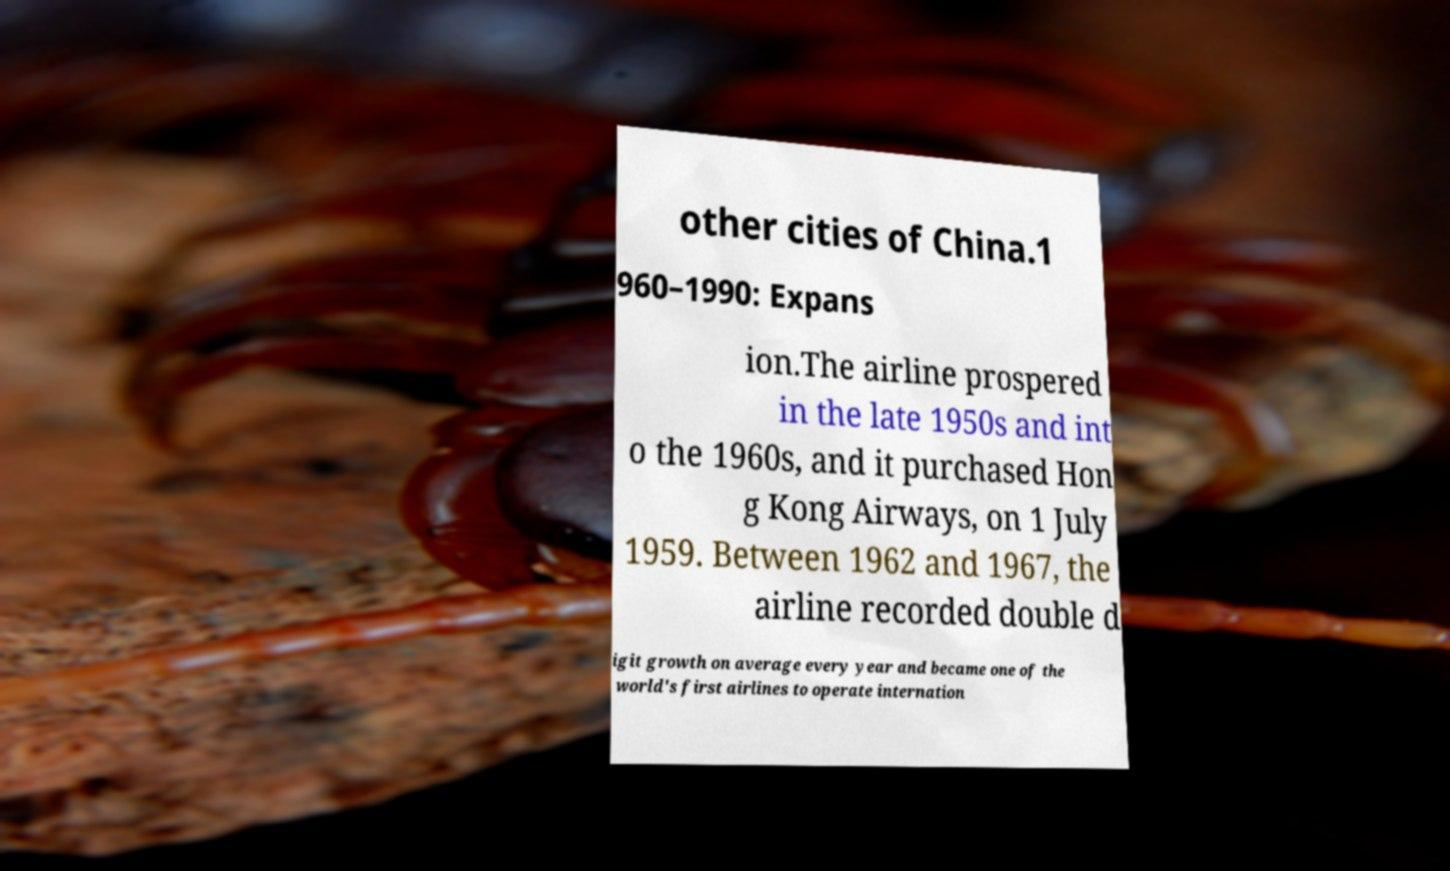Could you extract and type out the text from this image? other cities of China.1 960–1990: Expans ion.The airline prospered in the late 1950s and int o the 1960s, and it purchased Hon g Kong Airways, on 1 July 1959. Between 1962 and 1967, the airline recorded double d igit growth on average every year and became one of the world's first airlines to operate internation 